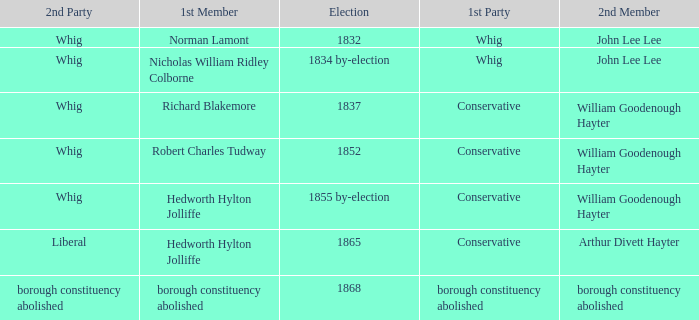What election has a 1st member of richard blakemore and a 2nd member of william goodenough hayter? 1837.0. 